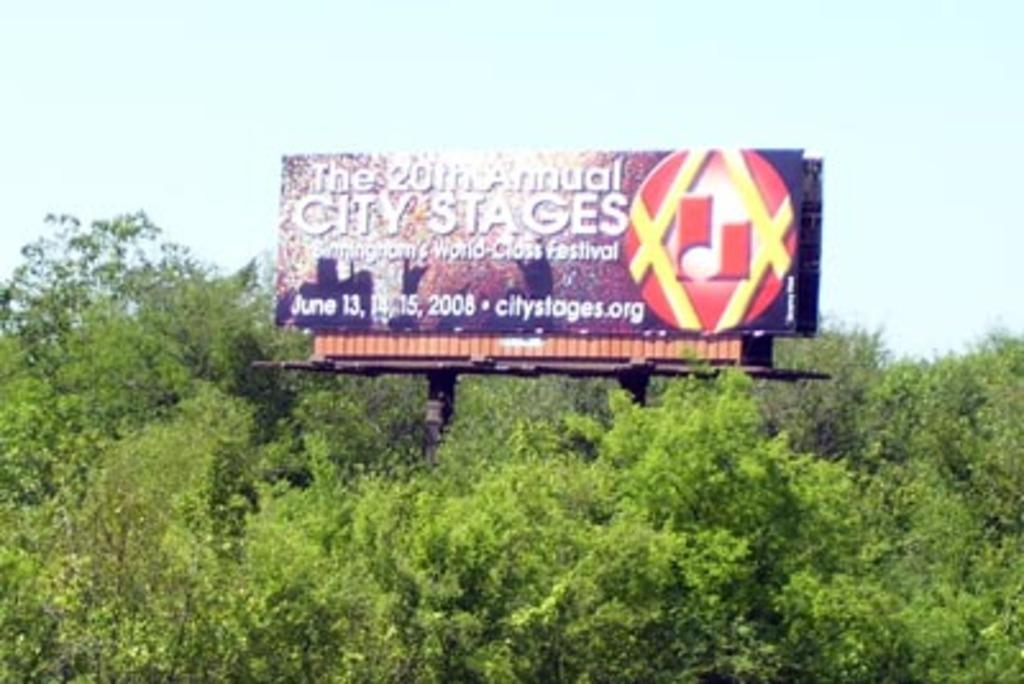<image>
Describe the image concisely. A billboard for the 20th annual City Stages festival. 